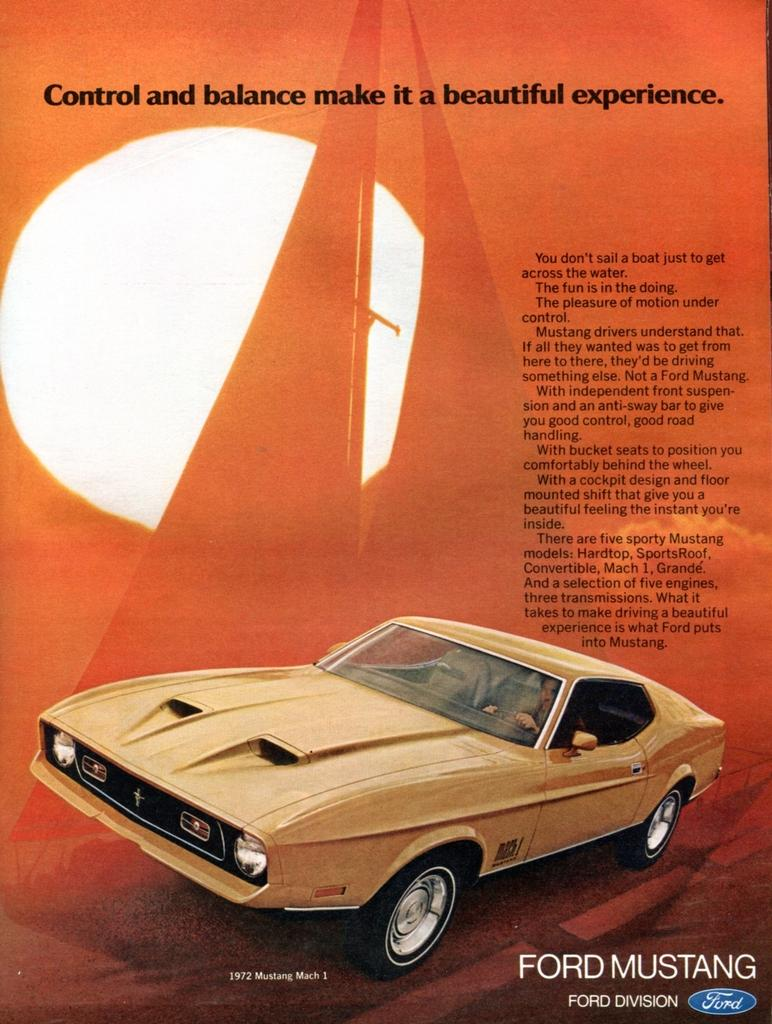What is the main subject of the image? There is a car in the image. What color is the car? The car is brown in color. Is there any text or writing present in the image? Yes, there is text or writing on the image. What color is the background of the image? The background of the image is orange. Can you see any celery growing in the background of the image? There is no celery present in the image; the background is orange. What type of train can be seen passing by the car in the image? There is no train present in the image; it only features a car. 